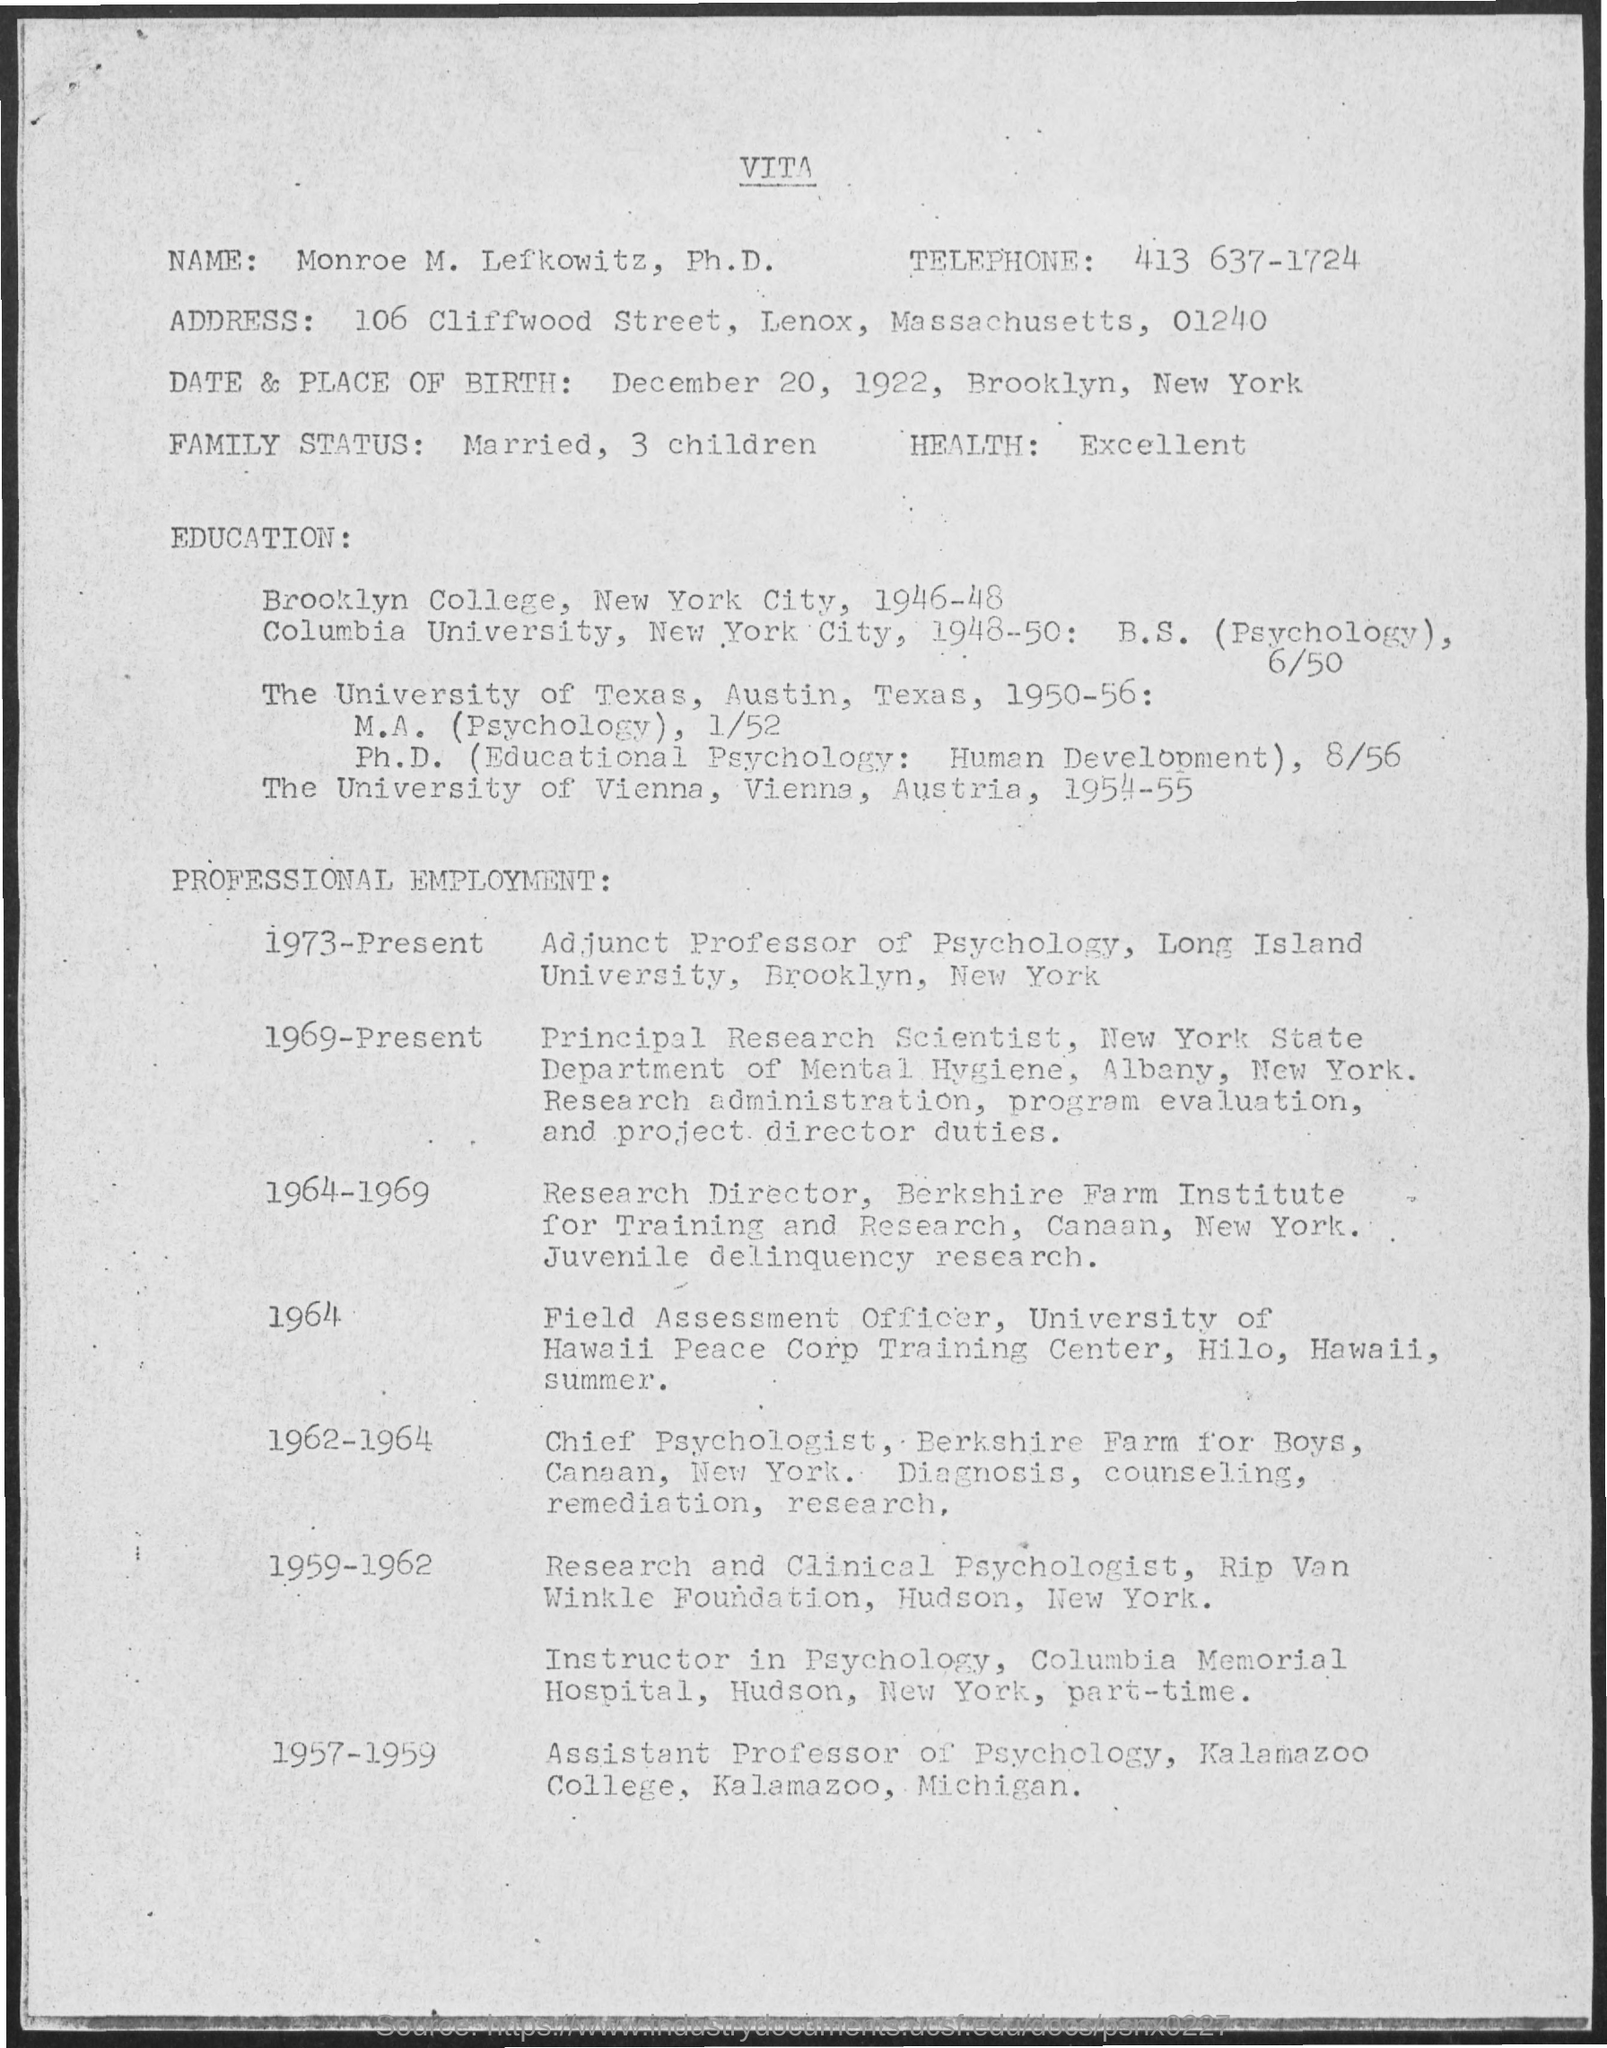Mention a couple of crucial points in this snapshot. The place of birth of Mr. Monroe is Brooklyn, New York. Mr. Monroe was born on December 20, 1922. Monroe completed his Ph.D. in Vienna, Austria at the University of Vienna. Mr. Monroe completed his M.A. in Psychology and Ph.D. in the years 1950-1956. Monroe worked as an Assistant Professor of Psychology from 1957 to 1959. 